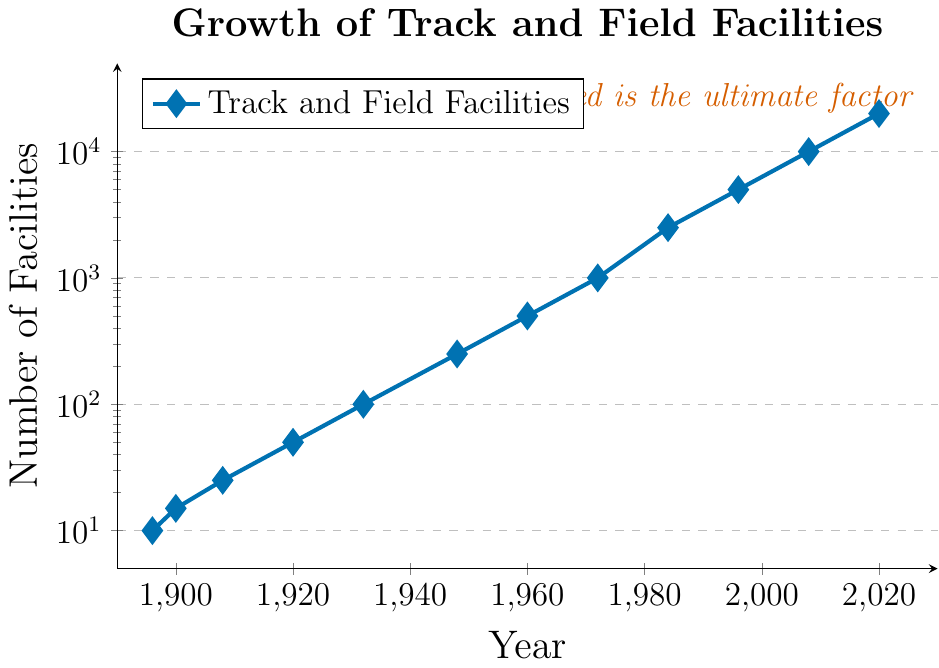what is the increase in the number of facilities from 1932 to 1948? In 1932, there were 100 facilities, and in 1948, there were 250. The increase is 250 - 100 = 150.
Answer: 150 when did the number of facilities first reach 1000? The number of facilities reached 1000 in 1972 as indicated by the data point for that year.
Answer: 1972 how many years did it take for the number of facilities to grow from 5000 to 10000? The number of facilities was 5000 in 1996 and reached 10000 in 2008. The difference in years is 2008 - 1996 = 12.
Answer: 12 which period saw the fastest growth between 1920 and 1972 or between 1972 and 2020? From 1920 to 1972, the number of facilities grew from 50 to 1000, an increase of 950 over 52 years. From 1972 to 2020, facilities grew from 1000 to 20000, an increase of 19000 over 48 years. The second period had a higher rate of increase.
Answer: 1972 to 2020 which year had double the number of facilities compared to 1960? In 1960, there were 500 facilities. Doubling that amount gives us 1000. The year 1972 had exactly 1000 facilities.
Answer: 1972 which color is used for the text note in the plot? The text note "Speed is the ultimate factor" at the top right of the plot is colored in red.
Answer: red what is the average number of facilities from the years 1984, 1996, and 2008? The number of facilities in these years are 2500, 5000, and 10000 respectively. Their average is (2500 + 5000 + 10000) / 3 = 17500 / 3 = 5833.33.
Answer: 5833.33 what is the median value of facilities across all the data points? Sorting the facility numbers [10, 15, 25, 50, 100, 250, 500, 1000, 2500, 5000, 10000, 20000], the middle values are 250 and 500. The median is (250 + 500) / 2 = 375.
Answer: 375 what are the years when the number of facilities was exactly at the gridlines on the y-axis? The gridlines on the y-axis are at 10, 100, 1000, and 10000. Facilities reached these in the years 1896 (10), 1932 (100), 1972 (1000), and 2008 (10000).
Answer: 1896, 1932, 1972, 2008 how does the growth trend appear in the logscale plot? Observing the logscale plot, the growth trend appears as a straight line, indicating exponential growth over time.
Answer: exponential 